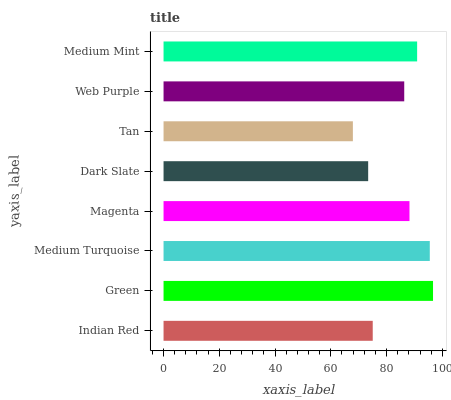Is Tan the minimum?
Answer yes or no. Yes. Is Green the maximum?
Answer yes or no. Yes. Is Medium Turquoise the minimum?
Answer yes or no. No. Is Medium Turquoise the maximum?
Answer yes or no. No. Is Green greater than Medium Turquoise?
Answer yes or no. Yes. Is Medium Turquoise less than Green?
Answer yes or no. Yes. Is Medium Turquoise greater than Green?
Answer yes or no. No. Is Green less than Medium Turquoise?
Answer yes or no. No. Is Magenta the high median?
Answer yes or no. Yes. Is Web Purple the low median?
Answer yes or no. Yes. Is Medium Mint the high median?
Answer yes or no. No. Is Medium Mint the low median?
Answer yes or no. No. 